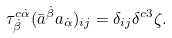Convert formula to latex. <formula><loc_0><loc_0><loc_500><loc_500>\tau _ { \dot { \beta } } ^ { c \dot { \alpha } } ( \bar { a } ^ { \dot { \beta } } a _ { \dot { \alpha } } ) _ { i j } = \delta _ { i j } \delta ^ { c 3 } \zeta .</formula> 